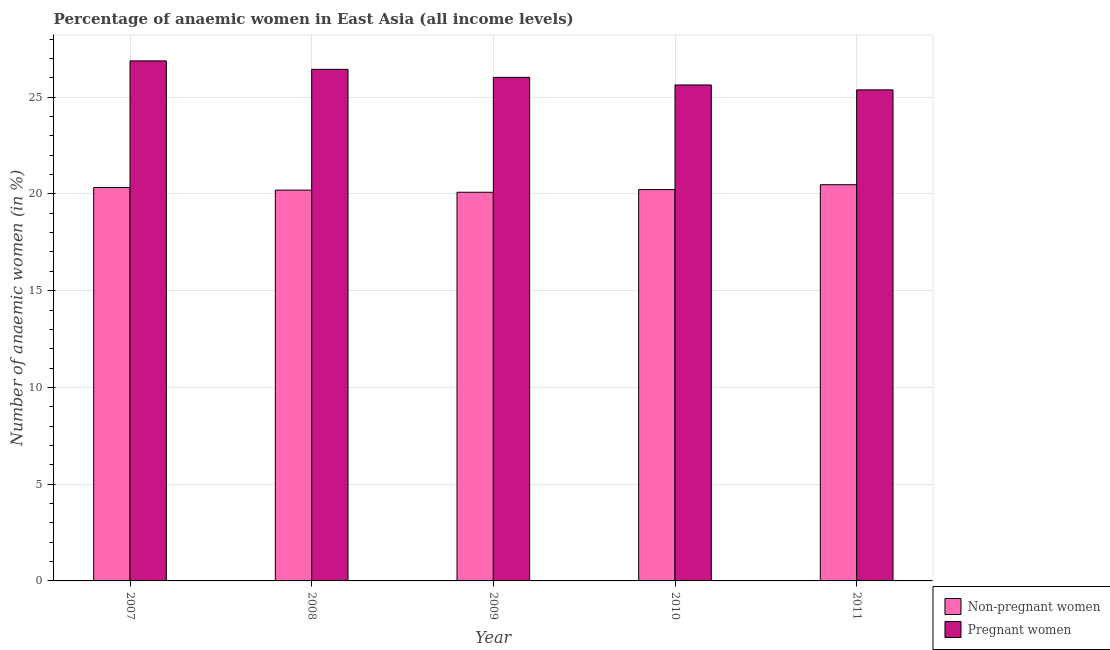Are the number of bars on each tick of the X-axis equal?
Provide a short and direct response. Yes. How many bars are there on the 3rd tick from the right?
Keep it short and to the point. 2. In how many cases, is the number of bars for a given year not equal to the number of legend labels?
Your answer should be very brief. 0. What is the percentage of pregnant anaemic women in 2009?
Provide a short and direct response. 26.02. Across all years, what is the maximum percentage of non-pregnant anaemic women?
Give a very brief answer. 20.48. Across all years, what is the minimum percentage of non-pregnant anaemic women?
Give a very brief answer. 20.09. In which year was the percentage of non-pregnant anaemic women minimum?
Offer a very short reply. 2009. What is the total percentage of non-pregnant anaemic women in the graph?
Your answer should be very brief. 101.32. What is the difference between the percentage of non-pregnant anaemic women in 2008 and that in 2011?
Offer a very short reply. -0.28. What is the difference between the percentage of non-pregnant anaemic women in 2011 and the percentage of pregnant anaemic women in 2010?
Make the answer very short. 0.25. What is the average percentage of non-pregnant anaemic women per year?
Make the answer very short. 20.26. In the year 2011, what is the difference between the percentage of pregnant anaemic women and percentage of non-pregnant anaemic women?
Your answer should be very brief. 0. In how many years, is the percentage of non-pregnant anaemic women greater than 1 %?
Your answer should be very brief. 5. What is the ratio of the percentage of pregnant anaemic women in 2010 to that in 2011?
Your answer should be compact. 1.01. Is the percentage of non-pregnant anaemic women in 2010 less than that in 2011?
Your answer should be very brief. Yes. Is the difference between the percentage of non-pregnant anaemic women in 2007 and 2009 greater than the difference between the percentage of pregnant anaemic women in 2007 and 2009?
Give a very brief answer. No. What is the difference between the highest and the second highest percentage of non-pregnant anaemic women?
Ensure brevity in your answer.  0.15. What is the difference between the highest and the lowest percentage of non-pregnant anaemic women?
Provide a short and direct response. 0.39. What does the 2nd bar from the left in 2009 represents?
Your answer should be very brief. Pregnant women. What does the 2nd bar from the right in 2009 represents?
Offer a terse response. Non-pregnant women. Are the values on the major ticks of Y-axis written in scientific E-notation?
Keep it short and to the point. No. Where does the legend appear in the graph?
Give a very brief answer. Bottom right. How many legend labels are there?
Your response must be concise. 2. What is the title of the graph?
Provide a succinct answer. Percentage of anaemic women in East Asia (all income levels). Does "RDB concessional" appear as one of the legend labels in the graph?
Your response must be concise. No. What is the label or title of the X-axis?
Make the answer very short. Year. What is the label or title of the Y-axis?
Give a very brief answer. Number of anaemic women (in %). What is the Number of anaemic women (in %) of Non-pregnant women in 2007?
Make the answer very short. 20.33. What is the Number of anaemic women (in %) in Pregnant women in 2007?
Keep it short and to the point. 26.88. What is the Number of anaemic women (in %) in Non-pregnant women in 2008?
Keep it short and to the point. 20.2. What is the Number of anaemic women (in %) of Pregnant women in 2008?
Provide a short and direct response. 26.44. What is the Number of anaemic women (in %) of Non-pregnant women in 2009?
Provide a short and direct response. 20.09. What is the Number of anaemic women (in %) in Pregnant women in 2009?
Keep it short and to the point. 26.02. What is the Number of anaemic women (in %) in Non-pregnant women in 2010?
Your answer should be very brief. 20.23. What is the Number of anaemic women (in %) in Pregnant women in 2010?
Offer a terse response. 25.63. What is the Number of anaemic women (in %) of Non-pregnant women in 2011?
Make the answer very short. 20.48. What is the Number of anaemic women (in %) in Pregnant women in 2011?
Provide a short and direct response. 25.38. Across all years, what is the maximum Number of anaemic women (in %) in Non-pregnant women?
Your response must be concise. 20.48. Across all years, what is the maximum Number of anaemic women (in %) of Pregnant women?
Make the answer very short. 26.88. Across all years, what is the minimum Number of anaemic women (in %) in Non-pregnant women?
Ensure brevity in your answer.  20.09. Across all years, what is the minimum Number of anaemic women (in %) in Pregnant women?
Ensure brevity in your answer.  25.38. What is the total Number of anaemic women (in %) of Non-pregnant women in the graph?
Give a very brief answer. 101.32. What is the total Number of anaemic women (in %) of Pregnant women in the graph?
Your answer should be compact. 130.35. What is the difference between the Number of anaemic women (in %) of Non-pregnant women in 2007 and that in 2008?
Ensure brevity in your answer.  0.13. What is the difference between the Number of anaemic women (in %) in Pregnant women in 2007 and that in 2008?
Provide a succinct answer. 0.44. What is the difference between the Number of anaemic women (in %) in Non-pregnant women in 2007 and that in 2009?
Your answer should be very brief. 0.24. What is the difference between the Number of anaemic women (in %) in Pregnant women in 2007 and that in 2009?
Offer a very short reply. 0.85. What is the difference between the Number of anaemic women (in %) in Non-pregnant women in 2007 and that in 2010?
Offer a very short reply. 0.11. What is the difference between the Number of anaemic women (in %) in Pregnant women in 2007 and that in 2010?
Give a very brief answer. 1.24. What is the difference between the Number of anaemic women (in %) of Non-pregnant women in 2007 and that in 2011?
Offer a very short reply. -0.15. What is the difference between the Number of anaemic women (in %) of Pregnant women in 2007 and that in 2011?
Make the answer very short. 1.5. What is the difference between the Number of anaemic women (in %) of Non-pregnant women in 2008 and that in 2009?
Keep it short and to the point. 0.11. What is the difference between the Number of anaemic women (in %) in Pregnant women in 2008 and that in 2009?
Your response must be concise. 0.42. What is the difference between the Number of anaemic women (in %) of Non-pregnant women in 2008 and that in 2010?
Your response must be concise. -0.03. What is the difference between the Number of anaemic women (in %) of Pregnant women in 2008 and that in 2010?
Your response must be concise. 0.81. What is the difference between the Number of anaemic women (in %) in Non-pregnant women in 2008 and that in 2011?
Your response must be concise. -0.28. What is the difference between the Number of anaemic women (in %) of Pregnant women in 2008 and that in 2011?
Your response must be concise. 1.06. What is the difference between the Number of anaemic women (in %) in Non-pregnant women in 2009 and that in 2010?
Ensure brevity in your answer.  -0.14. What is the difference between the Number of anaemic women (in %) in Pregnant women in 2009 and that in 2010?
Make the answer very short. 0.39. What is the difference between the Number of anaemic women (in %) in Non-pregnant women in 2009 and that in 2011?
Ensure brevity in your answer.  -0.39. What is the difference between the Number of anaemic women (in %) in Pregnant women in 2009 and that in 2011?
Your answer should be very brief. 0.65. What is the difference between the Number of anaemic women (in %) of Non-pregnant women in 2010 and that in 2011?
Offer a terse response. -0.25. What is the difference between the Number of anaemic women (in %) in Pregnant women in 2010 and that in 2011?
Ensure brevity in your answer.  0.25. What is the difference between the Number of anaemic women (in %) of Non-pregnant women in 2007 and the Number of anaemic women (in %) of Pregnant women in 2008?
Ensure brevity in your answer.  -6.11. What is the difference between the Number of anaemic women (in %) of Non-pregnant women in 2007 and the Number of anaemic women (in %) of Pregnant women in 2009?
Keep it short and to the point. -5.69. What is the difference between the Number of anaemic women (in %) of Non-pregnant women in 2007 and the Number of anaemic women (in %) of Pregnant women in 2010?
Provide a short and direct response. -5.3. What is the difference between the Number of anaemic women (in %) in Non-pregnant women in 2007 and the Number of anaemic women (in %) in Pregnant women in 2011?
Give a very brief answer. -5.05. What is the difference between the Number of anaemic women (in %) in Non-pregnant women in 2008 and the Number of anaemic women (in %) in Pregnant women in 2009?
Keep it short and to the point. -5.83. What is the difference between the Number of anaemic women (in %) of Non-pregnant women in 2008 and the Number of anaemic women (in %) of Pregnant women in 2010?
Give a very brief answer. -5.44. What is the difference between the Number of anaemic women (in %) of Non-pregnant women in 2008 and the Number of anaemic women (in %) of Pregnant women in 2011?
Make the answer very short. -5.18. What is the difference between the Number of anaemic women (in %) of Non-pregnant women in 2009 and the Number of anaemic women (in %) of Pregnant women in 2010?
Keep it short and to the point. -5.55. What is the difference between the Number of anaemic women (in %) of Non-pregnant women in 2009 and the Number of anaemic women (in %) of Pregnant women in 2011?
Provide a short and direct response. -5.29. What is the difference between the Number of anaemic women (in %) in Non-pregnant women in 2010 and the Number of anaemic women (in %) in Pregnant women in 2011?
Offer a terse response. -5.15. What is the average Number of anaemic women (in %) of Non-pregnant women per year?
Ensure brevity in your answer.  20.26. What is the average Number of anaemic women (in %) of Pregnant women per year?
Your answer should be very brief. 26.07. In the year 2007, what is the difference between the Number of anaemic women (in %) of Non-pregnant women and Number of anaemic women (in %) of Pregnant women?
Give a very brief answer. -6.55. In the year 2008, what is the difference between the Number of anaemic women (in %) of Non-pregnant women and Number of anaemic women (in %) of Pregnant women?
Keep it short and to the point. -6.24. In the year 2009, what is the difference between the Number of anaemic women (in %) in Non-pregnant women and Number of anaemic women (in %) in Pregnant women?
Offer a very short reply. -5.94. In the year 2010, what is the difference between the Number of anaemic women (in %) of Non-pregnant women and Number of anaemic women (in %) of Pregnant women?
Keep it short and to the point. -5.41. In the year 2011, what is the difference between the Number of anaemic women (in %) of Non-pregnant women and Number of anaemic women (in %) of Pregnant women?
Make the answer very short. -4.9. What is the ratio of the Number of anaemic women (in %) of Non-pregnant women in 2007 to that in 2008?
Make the answer very short. 1.01. What is the ratio of the Number of anaemic women (in %) in Pregnant women in 2007 to that in 2008?
Your answer should be compact. 1.02. What is the ratio of the Number of anaemic women (in %) of Non-pregnant women in 2007 to that in 2009?
Your answer should be compact. 1.01. What is the ratio of the Number of anaemic women (in %) in Pregnant women in 2007 to that in 2009?
Your answer should be compact. 1.03. What is the ratio of the Number of anaemic women (in %) in Non-pregnant women in 2007 to that in 2010?
Provide a short and direct response. 1.01. What is the ratio of the Number of anaemic women (in %) of Pregnant women in 2007 to that in 2010?
Your answer should be compact. 1.05. What is the ratio of the Number of anaemic women (in %) in Non-pregnant women in 2007 to that in 2011?
Offer a very short reply. 0.99. What is the ratio of the Number of anaemic women (in %) in Pregnant women in 2007 to that in 2011?
Your answer should be compact. 1.06. What is the ratio of the Number of anaemic women (in %) in Non-pregnant women in 2008 to that in 2009?
Ensure brevity in your answer.  1.01. What is the ratio of the Number of anaemic women (in %) in Pregnant women in 2008 to that in 2009?
Keep it short and to the point. 1.02. What is the ratio of the Number of anaemic women (in %) in Pregnant women in 2008 to that in 2010?
Your response must be concise. 1.03. What is the ratio of the Number of anaemic women (in %) in Non-pregnant women in 2008 to that in 2011?
Provide a succinct answer. 0.99. What is the ratio of the Number of anaemic women (in %) in Pregnant women in 2008 to that in 2011?
Your response must be concise. 1.04. What is the ratio of the Number of anaemic women (in %) in Pregnant women in 2009 to that in 2010?
Your response must be concise. 1.02. What is the ratio of the Number of anaemic women (in %) of Non-pregnant women in 2009 to that in 2011?
Make the answer very short. 0.98. What is the ratio of the Number of anaemic women (in %) of Pregnant women in 2009 to that in 2011?
Make the answer very short. 1.03. What is the ratio of the Number of anaemic women (in %) in Non-pregnant women in 2010 to that in 2011?
Your answer should be very brief. 0.99. What is the difference between the highest and the second highest Number of anaemic women (in %) of Non-pregnant women?
Your response must be concise. 0.15. What is the difference between the highest and the second highest Number of anaemic women (in %) in Pregnant women?
Provide a short and direct response. 0.44. What is the difference between the highest and the lowest Number of anaemic women (in %) of Non-pregnant women?
Keep it short and to the point. 0.39. What is the difference between the highest and the lowest Number of anaemic women (in %) in Pregnant women?
Give a very brief answer. 1.5. 